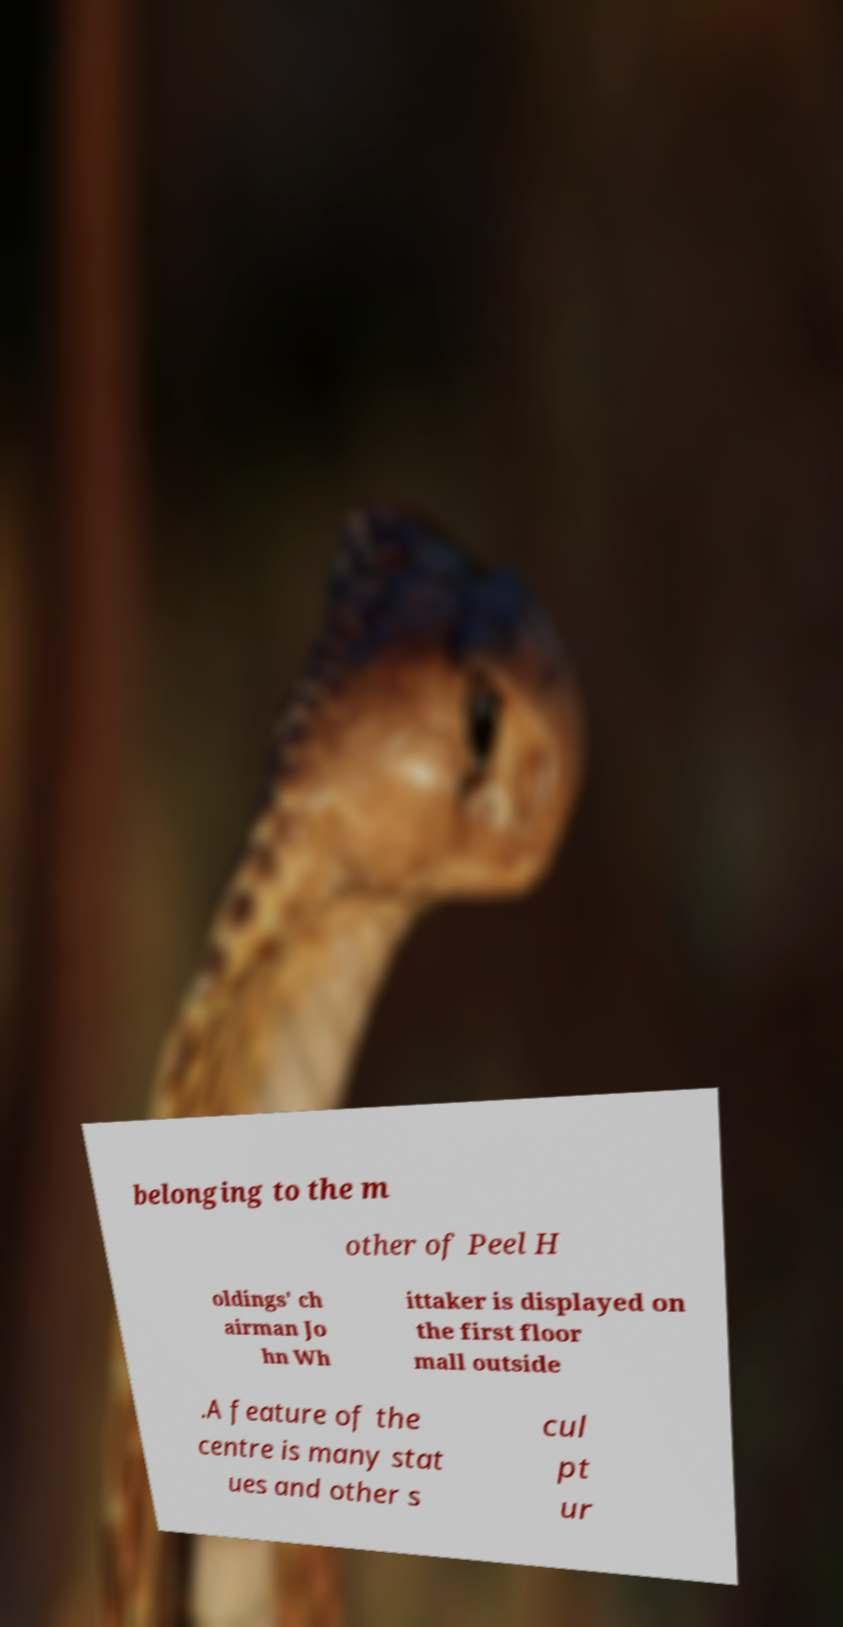Please identify and transcribe the text found in this image. belonging to the m other of Peel H oldings' ch airman Jo hn Wh ittaker is displayed on the first floor mall outside .A feature of the centre is many stat ues and other s cul pt ur 